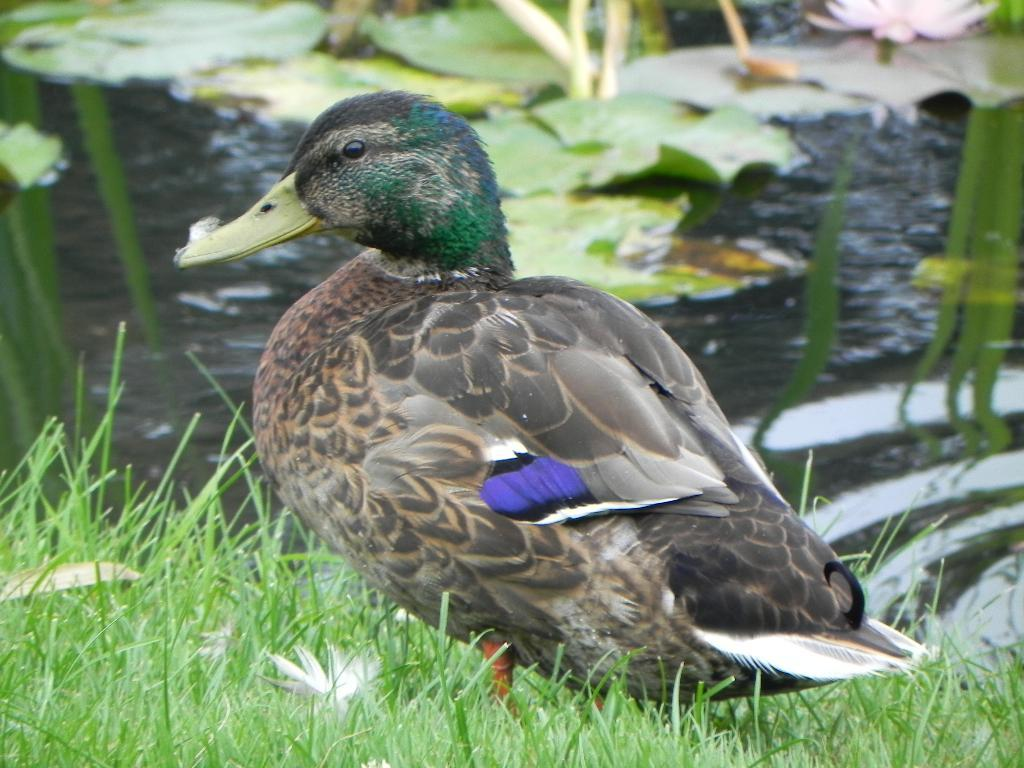What animal is present in the image? There is a duck in the picture. Where is the duck located? The duck is standing on the grass. What is visible behind the duck? There is a water surface behind the duck. What type of record is the duck holding in the image? The duck is not holding any record in the image; it is simply standing on the grass. 